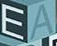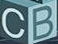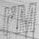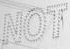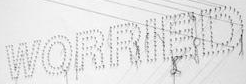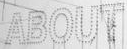Identify the words shown in these images in order, separated by a semicolon. EA; CB; I'M; NOT; WORRIED; ABOUT 